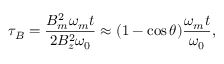<formula> <loc_0><loc_0><loc_500><loc_500>\tau _ { B } = \frac { B _ { m } ^ { 2 } \omega _ { m } t } { 2 B _ { z } ^ { 2 } \omega _ { 0 } } \approx ( 1 - \cos \theta ) \frac { \omega _ { m } t } { \omega _ { 0 } } ,</formula> 